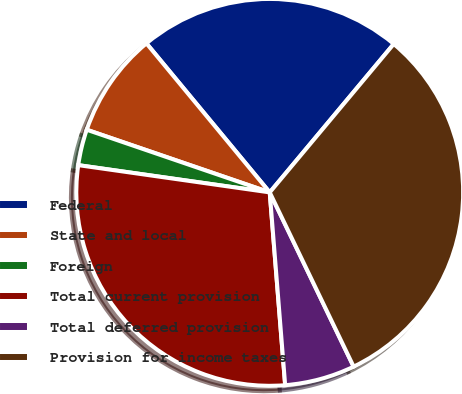Convert chart to OTSL. <chart><loc_0><loc_0><loc_500><loc_500><pie_chart><fcel>Federal<fcel>State and local<fcel>Foreign<fcel>Total current provision<fcel>Total deferred provision<fcel>Provision for income taxes<nl><fcel>22.08%<fcel>8.75%<fcel>3.0%<fcel>28.52%<fcel>5.87%<fcel>31.78%<nl></chart> 